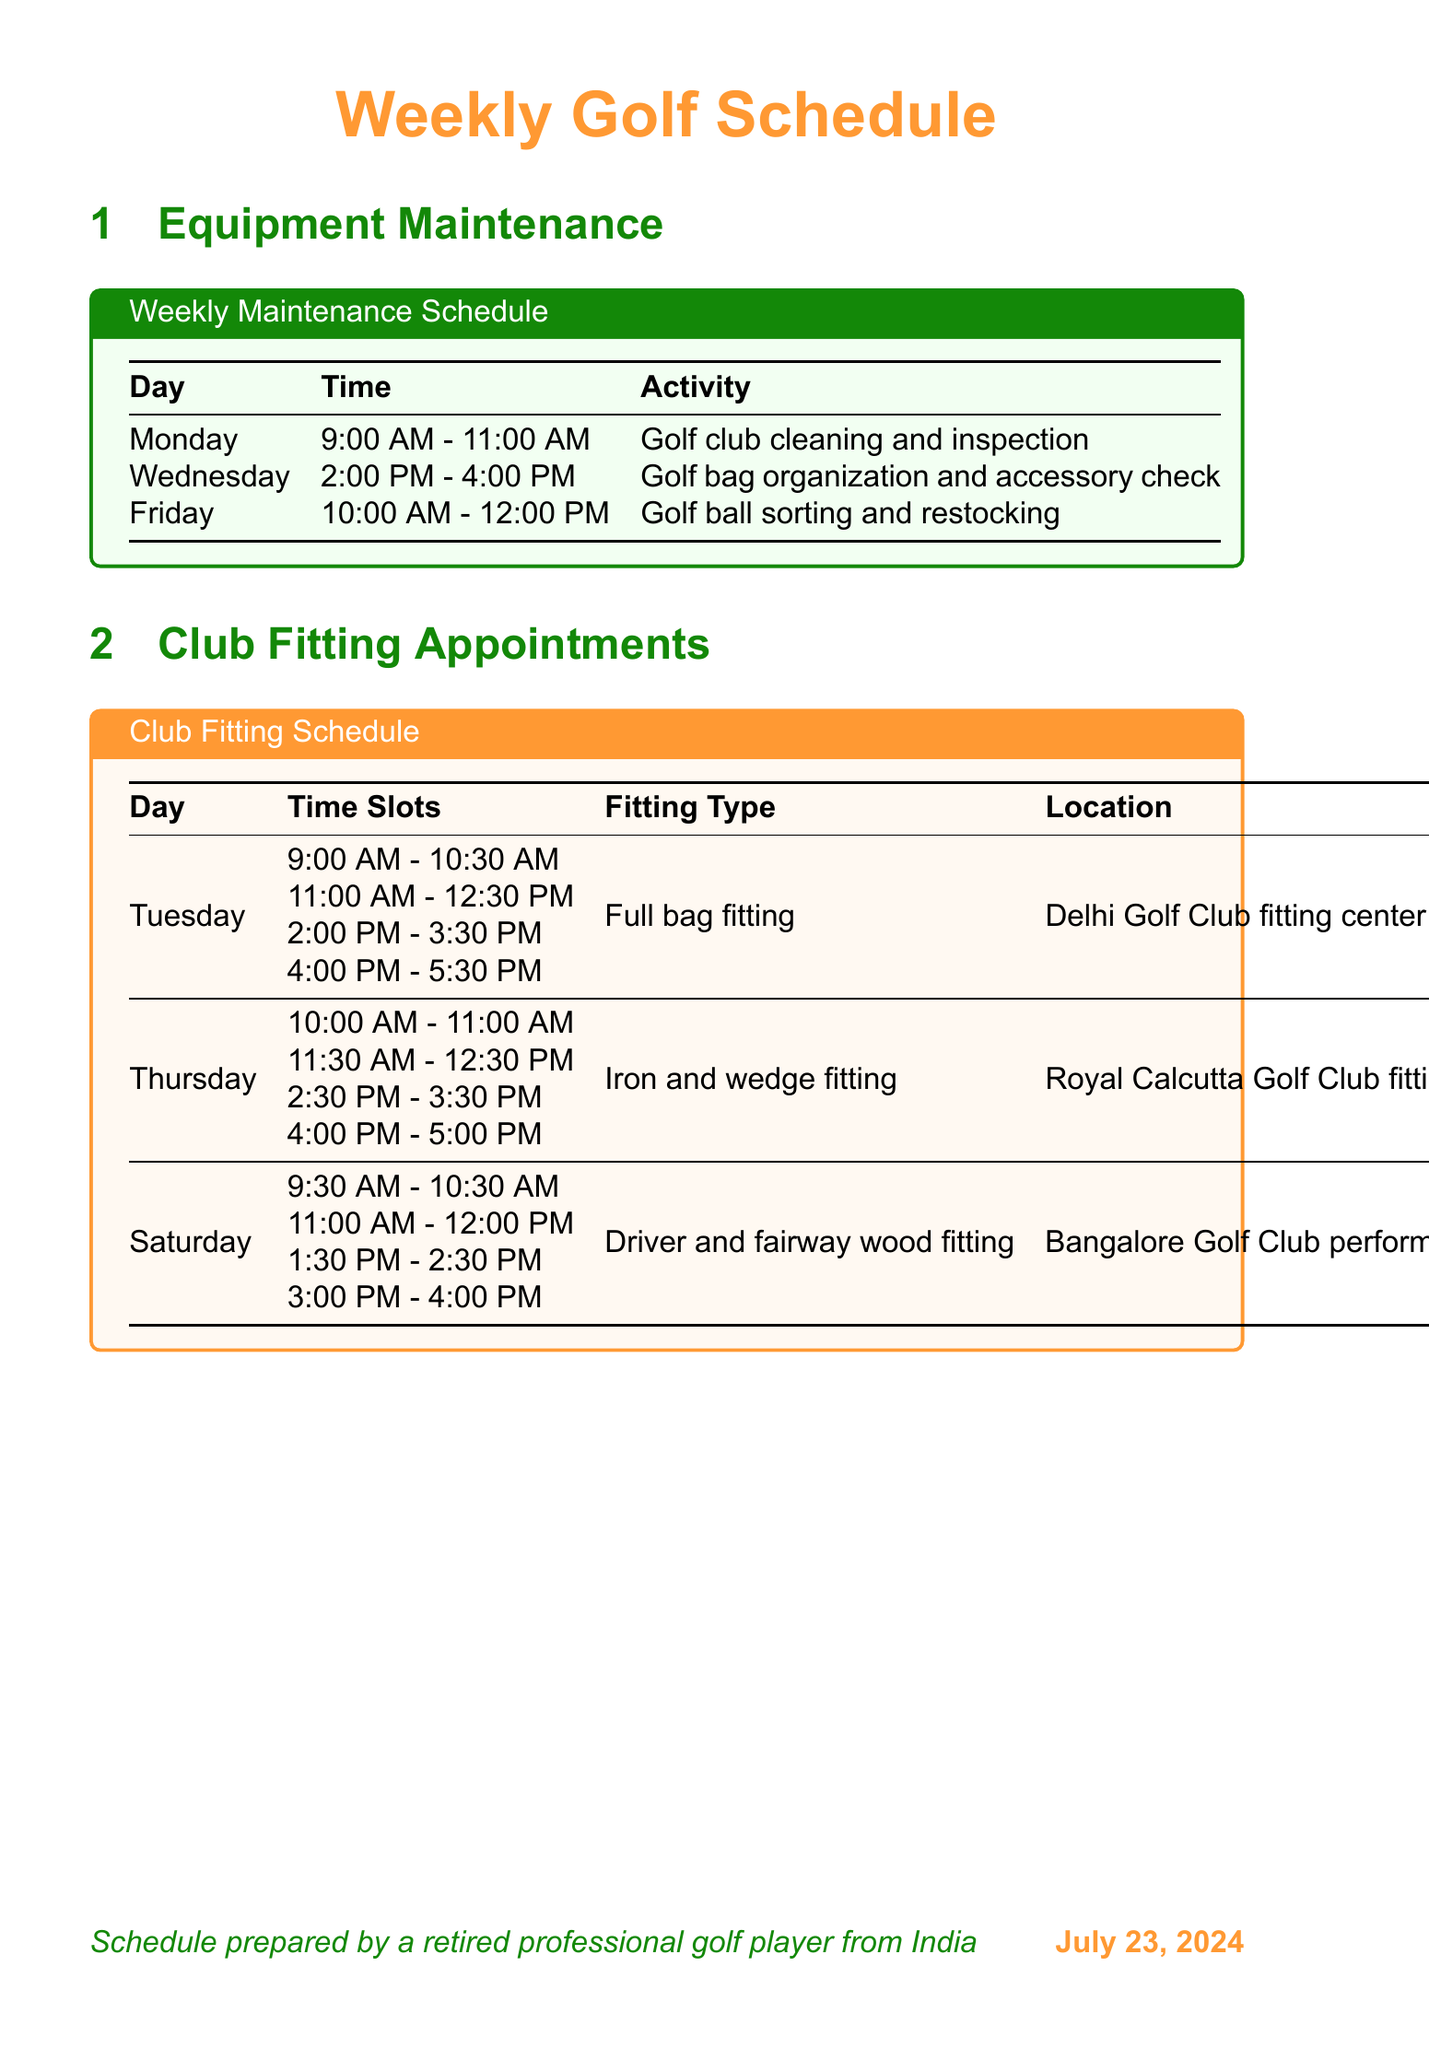What day is the golf club cleaning activity scheduled? The golf club cleaning activity is listed under the Equipment Maintenance section of the document, scheduled for Monday.
Answer: Monday How many time slots are available for the Full bag fitting on Tuesday? The Full bag fitting has four time slots available on Tuesday, as detailed in the Club Fitting Schedule.
Answer: Four What time does the short game skills evaluation start on Wednesday? The document specifies that the assessment begins at 9:00 AM on Wednesday under the Individual Assessments section.
Answer: 9:00 AM Which golf club is used for the physical fitness assessment on Friday? The physical fitness and flexibility assessment for golf takes place at the Bombay Presidency Golf Club, as mentioned in the assessment section.
Answer: Bombay Presidency Golf Club What is the activity scheduled between 10:00 AM and 12:00 PM on Friday? The document details that Golf ball sorting and restocking is scheduled during that time on Friday in the Equipment Maintenance section.
Answer: Golf ball sorting and restocking Which fitting type occurs at the Royal Calcutta Golf Club on Thursday? The document indicates that Iron and wedge fitting is scheduled at the Royal Calcutta Golf Club on Thursday in the Club Fitting Appointments section.
Answer: Iron and wedge fitting What assessment technique is used on Monday for individual assessments? The assessment technique mentioned for Monday is Swing analysis using TrackMan launch monitor, as stated in the Individual Assessments section.
Answer: Swing analysis using TrackMan launch monitor How many brands of golf equipment are listed? The document contains a list of seven different equipment brands in the Additional Information section.
Answer: Seven What day is the golf bag organization activity scheduled? The document lists the Golf bag organization and accessory check activity, scheduled for Wednesday in the Equipment Maintenance section.
Answer: Wednesday 